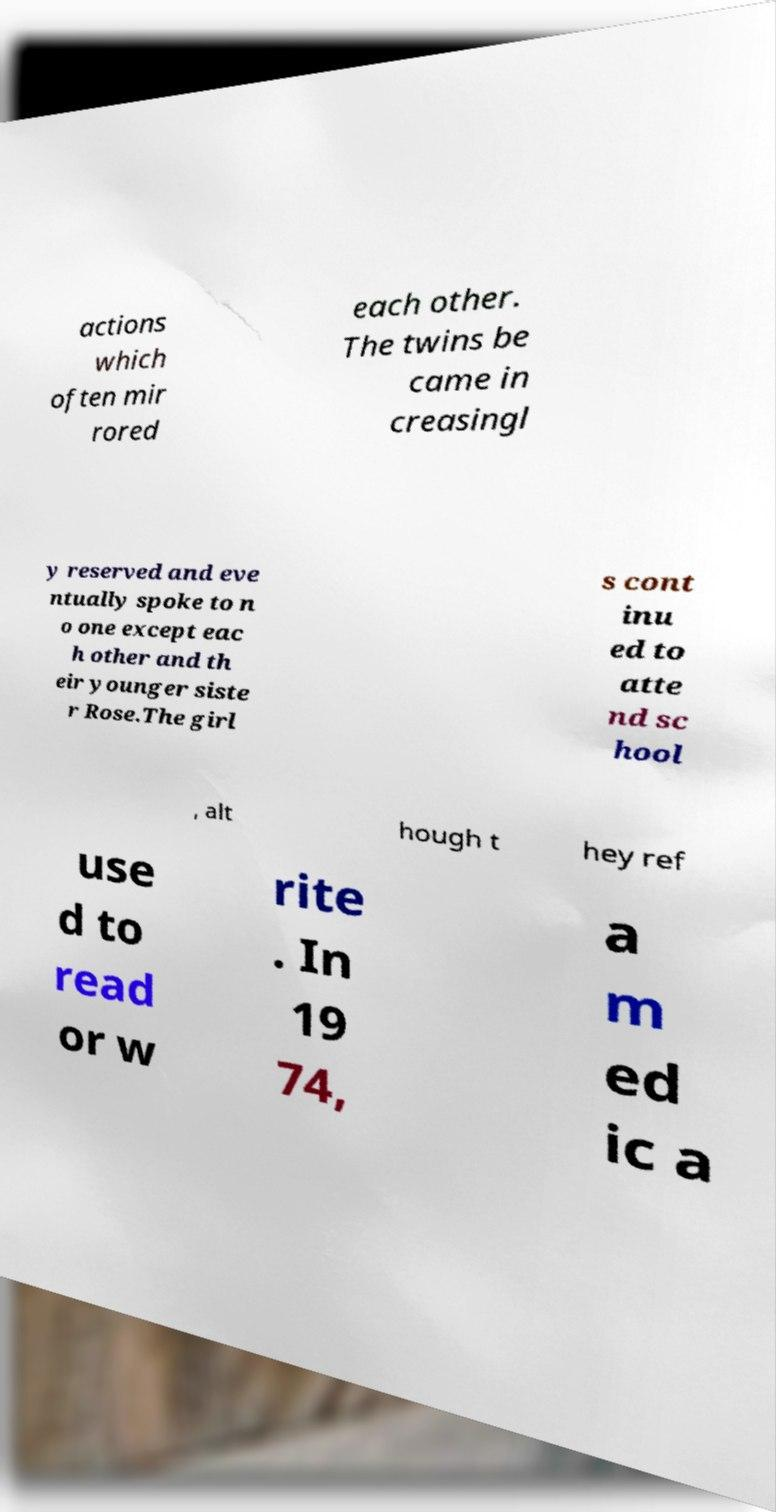Can you read and provide the text displayed in the image?This photo seems to have some interesting text. Can you extract and type it out for me? actions which often mir rored each other. The twins be came in creasingl y reserved and eve ntually spoke to n o one except eac h other and th eir younger siste r Rose.The girl s cont inu ed to atte nd sc hool , alt hough t hey ref use d to read or w rite . In 19 74, a m ed ic a 